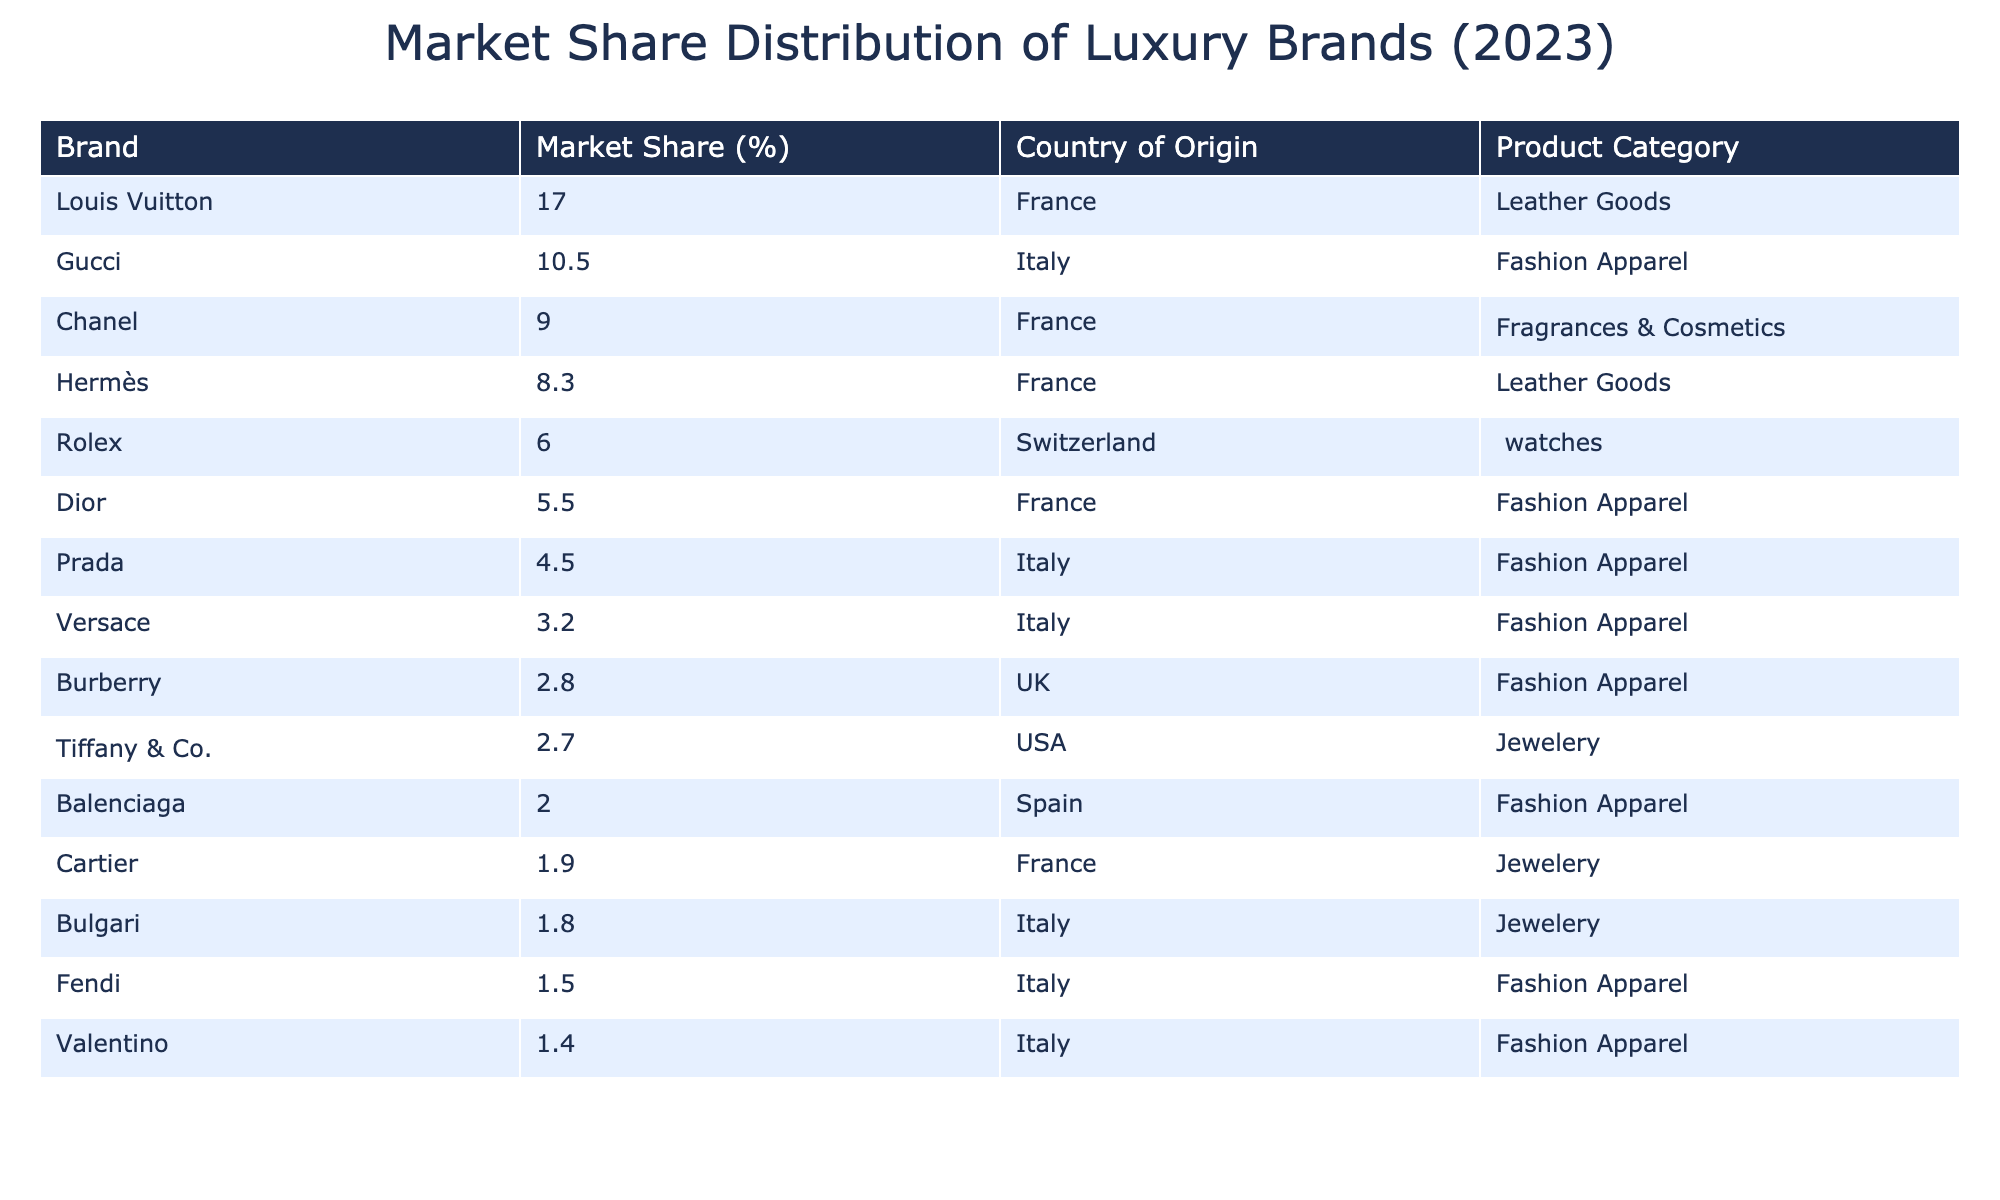What is the market share percentage of Louis Vuitton? The table shows the market share percentages of various luxury brands, and it indicates that Louis Vuitton has a market share of 17.0%.
Answer: 17.0% Which country of origin does Cartier belong to? By looking at the table, Cartier is listed with France as its country of origin.
Answer: France What is the total market share of the top three luxury brands? The top three luxury brands are Louis Vuitton (17.0%), Gucci (10.5%), and Chanel (9.0%). Summing their market shares gives 17.0 + 10.5 + 9.0 = 36.5%.
Answer: 36.5% Is the market share of Rolex greater than that of Dior? The market share of Rolex is 6.0%, and for Dior, it is 5.5%. Since 6.0% is greater than 5.5%, the statement is true.
Answer: Yes What is the average market share of Italian luxury brands listed in the table? The Italian brands are Gucci (10.5%), Prada (4.5%), Versace (3.2%), Bulgari (1.8%), Fendi (1.5%), and Valentino (1.4%). Adding these gives 10.5 + 4.5 + 3.2 + 1.8 + 1.5 + 1.4 = 23.9%. There are 6 Italian brands, so the average is 23.9% / 6 = 3.9833% (approximately 3.98%).
Answer: 3.98% Which product category has the largest cumulative market share? The product categories are Leather Goods, Fashion Apparel, Fragrances & Cosmetics, Watches, and Jewelry. Summing the market shares, Leather Goods has 17.0 + 8.3 = 25.3%, Fashion Apparel has 10.5 + 5.5 + 4.5 + 3.2 + 2.8 + 2.0 + 1.5 + 1.4 = 42.6%, Fragrances & Cosmetics is 9.0%, Watches is 6.0%, and Jewelry is 2.7 + 1.9 + 1.8 = 6.4%. The largest cumulative market share is from Fashion Apparel at 42.6%.
Answer: Fashion Apparel What percentage of the market does Hermès hold compared to Burberry? Hermès has a market share of 8.3% while Burberry has a market share of 2.8%. To find how much higher Hermès is compared to Burberry, subtract the two: 8.3 - 2.8 = 5.5%. Hermès has a market share that is 5.5% greater than Burberry.
Answer: 5.5% 